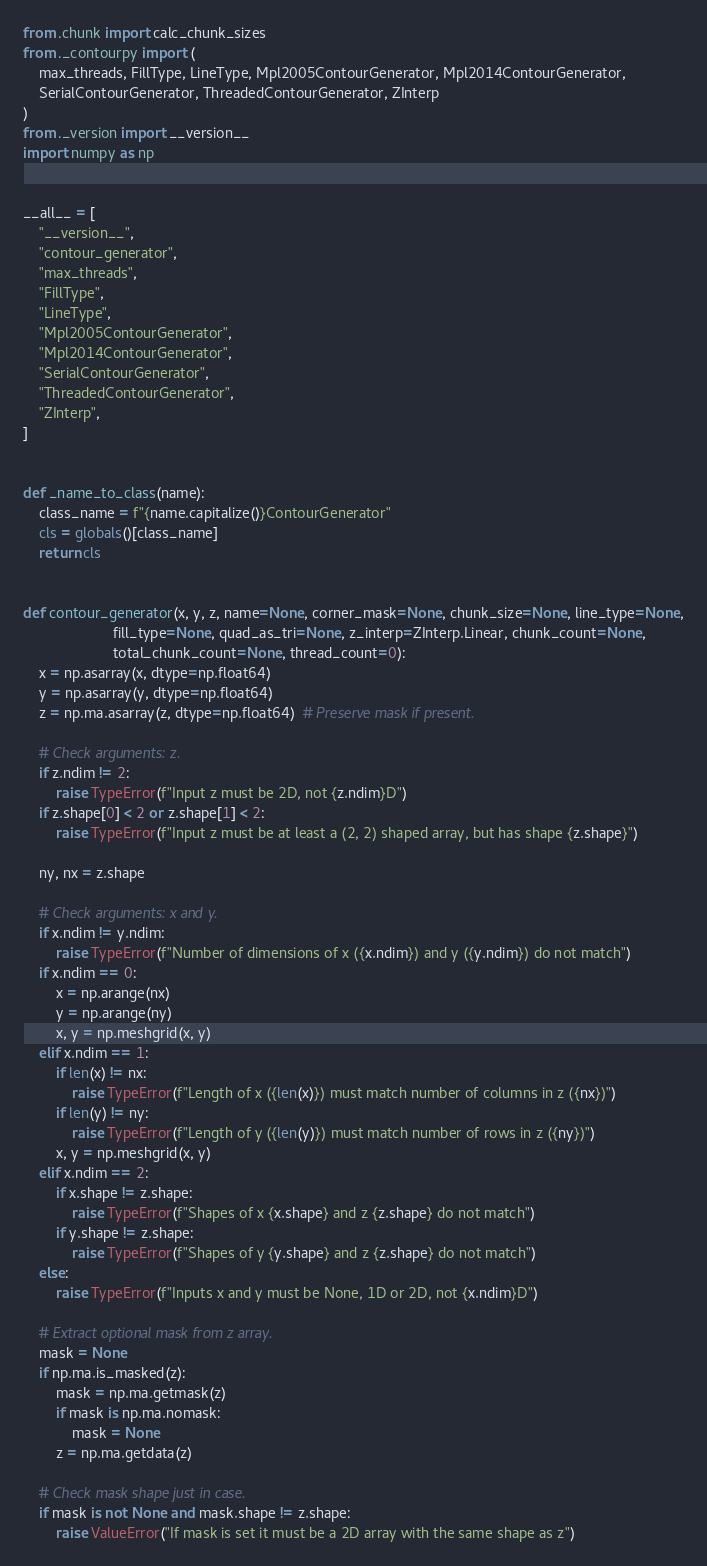<code> <loc_0><loc_0><loc_500><loc_500><_Python_>from .chunk import calc_chunk_sizes
from ._contourpy import (
    max_threads, FillType, LineType, Mpl2005ContourGenerator, Mpl2014ContourGenerator,
    SerialContourGenerator, ThreadedContourGenerator, ZInterp
)
from ._version import __version__
import numpy as np


__all__ = [
    "__version__",
    "contour_generator",
    "max_threads",
    "FillType",
    "LineType",
    "Mpl2005ContourGenerator",
    "Mpl2014ContourGenerator",
    "SerialContourGenerator",
    "ThreadedContourGenerator",
    "ZInterp",
]


def _name_to_class(name):
    class_name = f"{name.capitalize()}ContourGenerator"
    cls = globals()[class_name]
    return cls


def contour_generator(x, y, z, name=None, corner_mask=None, chunk_size=None, line_type=None,
                      fill_type=None, quad_as_tri=None, z_interp=ZInterp.Linear, chunk_count=None,
                      total_chunk_count=None, thread_count=0):
    x = np.asarray(x, dtype=np.float64)
    y = np.asarray(y, dtype=np.float64)
    z = np.ma.asarray(z, dtype=np.float64)  # Preserve mask if present.

    # Check arguments: z.
    if z.ndim != 2:
        raise TypeError(f"Input z must be 2D, not {z.ndim}D")
    if z.shape[0] < 2 or z.shape[1] < 2:
        raise TypeError(f"Input z must be at least a (2, 2) shaped array, but has shape {z.shape}")

    ny, nx = z.shape

    # Check arguments: x and y.
    if x.ndim != y.ndim:
        raise TypeError(f"Number of dimensions of x ({x.ndim}) and y ({y.ndim}) do not match")
    if x.ndim == 0:
        x = np.arange(nx)
        y = np.arange(ny)
        x, y = np.meshgrid(x, y)
    elif x.ndim == 1:
        if len(x) != nx:
            raise TypeError(f"Length of x ({len(x)}) must match number of columns in z ({nx})")
        if len(y) != ny:
            raise TypeError(f"Length of y ({len(y)}) must match number of rows in z ({ny})")
        x, y = np.meshgrid(x, y)
    elif x.ndim == 2:
        if x.shape != z.shape:
            raise TypeError(f"Shapes of x {x.shape} and z {z.shape} do not match")
        if y.shape != z.shape:
            raise TypeError(f"Shapes of y {y.shape} and z {z.shape} do not match")
    else:
        raise TypeError(f"Inputs x and y must be None, 1D or 2D, not {x.ndim}D")

    # Extract optional mask from z array.
    mask = None
    if np.ma.is_masked(z):
        mask = np.ma.getmask(z)
        if mask is np.ma.nomask:
            mask = None
        z = np.ma.getdata(z)

    # Check mask shape just in case.
    if mask is not None and mask.shape != z.shape:
        raise ValueError("If mask is set it must be a 2D array with the same shape as z")
</code> 